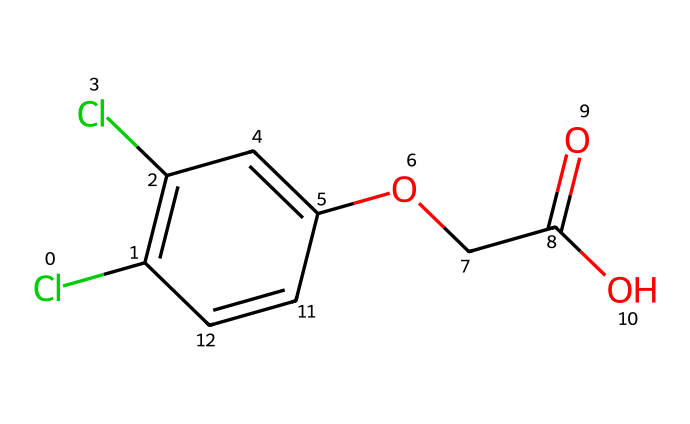What is the total number of carbon atoms in 2,4-D? By examining the SMILES representation, we identify the carbon atoms: there are 6 carbon atoms in the aromatic ring (C1=C, C=C, and the other C atoms connected), plus 2 from the ester part (OCC), totaling 8.
Answer: 8 How many chlorine atoms are present in 2,4-D? Looking at the SMILES structure, we see 'Cl' appears twice, indicating that there are two chlorine atoms attached to the aromatic ring.
Answer: 2 What type of functional groups are present in 2,4-D? Analyzing the molecular composition, we can identify an ester group (OCC(=O)) and a phenolic hydroxyl group (OH) in the structure, indicating the presence of both functional groups.
Answer: ester and phenolic Which part of the structure is responsible for its herbicidal activity? The presence of the chlorophenoxy group (the aromatic ring with chlorine substituents) is key for its herbicidal activity since it mimics auxins, which are growth hormones in plants.
Answer: chlorophenoxy group What is the molecular weight of 2,4-D? Calculating the molecular weight involves adding the atomic weights of all atoms present: 8 carbon (8*12), 7 hydrogen (7*1), 2 chlorine (2*35.5), and 5 oxygen (5*16). The total is approximately 221. The precise calculation leads to a finalized number.
Answer: 221 How many double bonds are in the structure of 2,4-D? In the SMILES representation, you can see that there are two double bonds present in the aromatic ring, which are indicated by the '=' sign between the carbon atoms.
Answer: 2 